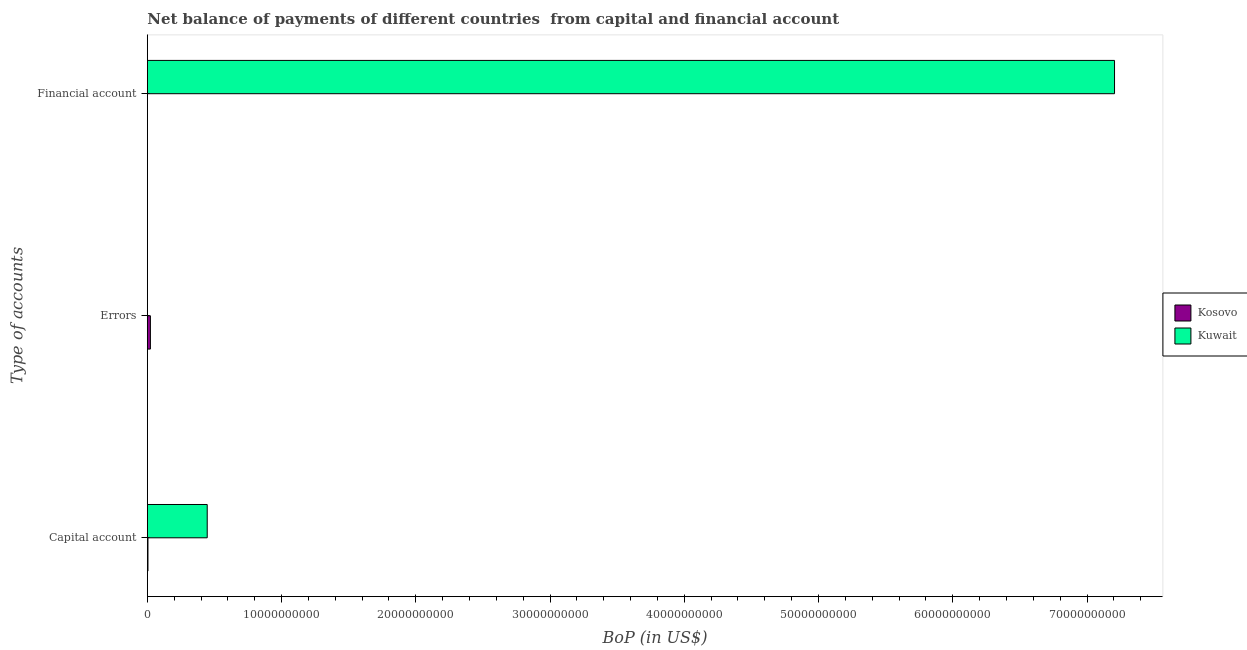Are the number of bars per tick equal to the number of legend labels?
Offer a terse response. No. How many bars are there on the 2nd tick from the top?
Offer a terse response. 1. What is the label of the 3rd group of bars from the top?
Make the answer very short. Capital account. Across all countries, what is the maximum amount of errors?
Your response must be concise. 2.28e+08. Across all countries, what is the minimum amount of net capital account?
Offer a very short reply. 4.63e+07. In which country was the amount of financial account maximum?
Your response must be concise. Kuwait. What is the total amount of financial account in the graph?
Offer a very short reply. 7.21e+1. What is the difference between the amount of net capital account in Kosovo and that in Kuwait?
Keep it short and to the point. -4.41e+09. What is the difference between the amount of financial account in Kuwait and the amount of net capital account in Kosovo?
Give a very brief answer. 7.20e+1. What is the average amount of net capital account per country?
Offer a very short reply. 2.25e+09. What is the difference between the amount of errors and amount of net capital account in Kosovo?
Offer a very short reply. 1.82e+08. What is the ratio of the amount of net capital account in Kosovo to that in Kuwait?
Provide a short and direct response. 0.01. What is the difference between the highest and the second highest amount of net capital account?
Provide a short and direct response. 4.41e+09. What is the difference between the highest and the lowest amount of financial account?
Offer a very short reply. 7.21e+1. In how many countries, is the amount of net capital account greater than the average amount of net capital account taken over all countries?
Provide a succinct answer. 1. How many bars are there?
Give a very brief answer. 4. How many countries are there in the graph?
Offer a very short reply. 2. Are the values on the major ticks of X-axis written in scientific E-notation?
Provide a short and direct response. No. Does the graph contain any zero values?
Your answer should be very brief. Yes. Where does the legend appear in the graph?
Provide a succinct answer. Center right. How many legend labels are there?
Keep it short and to the point. 2. How are the legend labels stacked?
Provide a succinct answer. Vertical. What is the title of the graph?
Keep it short and to the point. Net balance of payments of different countries  from capital and financial account. Does "Canada" appear as one of the legend labels in the graph?
Provide a short and direct response. No. What is the label or title of the X-axis?
Offer a very short reply. BoP (in US$). What is the label or title of the Y-axis?
Your response must be concise. Type of accounts. What is the BoP (in US$) of Kosovo in Capital account?
Your answer should be very brief. 4.63e+07. What is the BoP (in US$) in Kuwait in Capital account?
Make the answer very short. 4.46e+09. What is the BoP (in US$) of Kosovo in Errors?
Your answer should be very brief. 2.28e+08. What is the BoP (in US$) of Kuwait in Financial account?
Give a very brief answer. 7.21e+1. Across all Type of accounts, what is the maximum BoP (in US$) in Kosovo?
Give a very brief answer. 2.28e+08. Across all Type of accounts, what is the maximum BoP (in US$) of Kuwait?
Give a very brief answer. 7.21e+1. Across all Type of accounts, what is the minimum BoP (in US$) in Kosovo?
Make the answer very short. 0. What is the total BoP (in US$) in Kosovo in the graph?
Make the answer very short. 2.75e+08. What is the total BoP (in US$) in Kuwait in the graph?
Offer a terse response. 7.65e+1. What is the difference between the BoP (in US$) of Kosovo in Capital account and that in Errors?
Your response must be concise. -1.82e+08. What is the difference between the BoP (in US$) of Kuwait in Capital account and that in Financial account?
Ensure brevity in your answer.  -6.76e+1. What is the difference between the BoP (in US$) in Kosovo in Capital account and the BoP (in US$) in Kuwait in Financial account?
Give a very brief answer. -7.20e+1. What is the difference between the BoP (in US$) in Kosovo in Errors and the BoP (in US$) in Kuwait in Financial account?
Offer a terse response. -7.18e+1. What is the average BoP (in US$) in Kosovo per Type of accounts?
Provide a succinct answer. 9.15e+07. What is the average BoP (in US$) in Kuwait per Type of accounts?
Keep it short and to the point. 2.55e+1. What is the difference between the BoP (in US$) of Kosovo and BoP (in US$) of Kuwait in Capital account?
Provide a succinct answer. -4.41e+09. What is the ratio of the BoP (in US$) of Kosovo in Capital account to that in Errors?
Your answer should be compact. 0.2. What is the ratio of the BoP (in US$) in Kuwait in Capital account to that in Financial account?
Keep it short and to the point. 0.06. What is the difference between the highest and the lowest BoP (in US$) of Kosovo?
Your response must be concise. 2.28e+08. What is the difference between the highest and the lowest BoP (in US$) of Kuwait?
Your answer should be compact. 7.21e+1. 